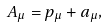<formula> <loc_0><loc_0><loc_500><loc_500>A _ { \mu } = p _ { \mu } + a _ { \mu } ,</formula> 